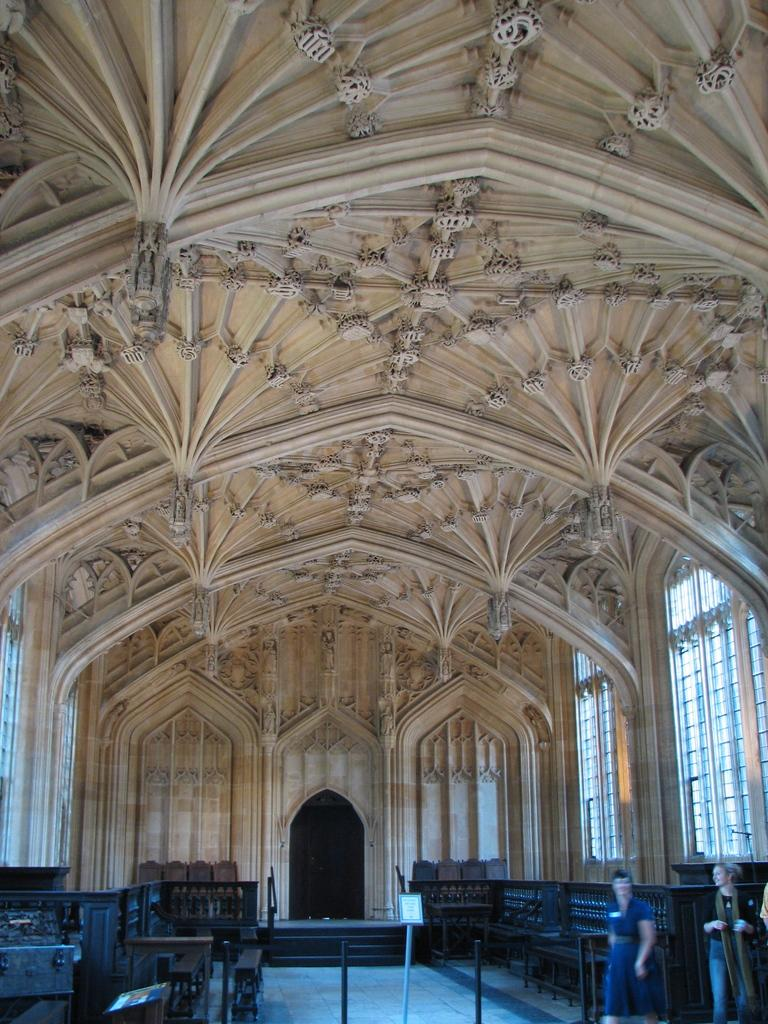What type of structure is depicted in the image? There is a building in the image, which appears to be a church. Where was the image taken? The image was taken inside the building. What can be seen on either side of the image? There are benches on the left and right sides of the image. What is visible at the bottom of the image? There is a floor visible at the bottom of the image. What type of fruit is hanging from the ceiling in the image? There is no fruit hanging from the ceiling in the image; it depicts a church interior with benches and a floor. 